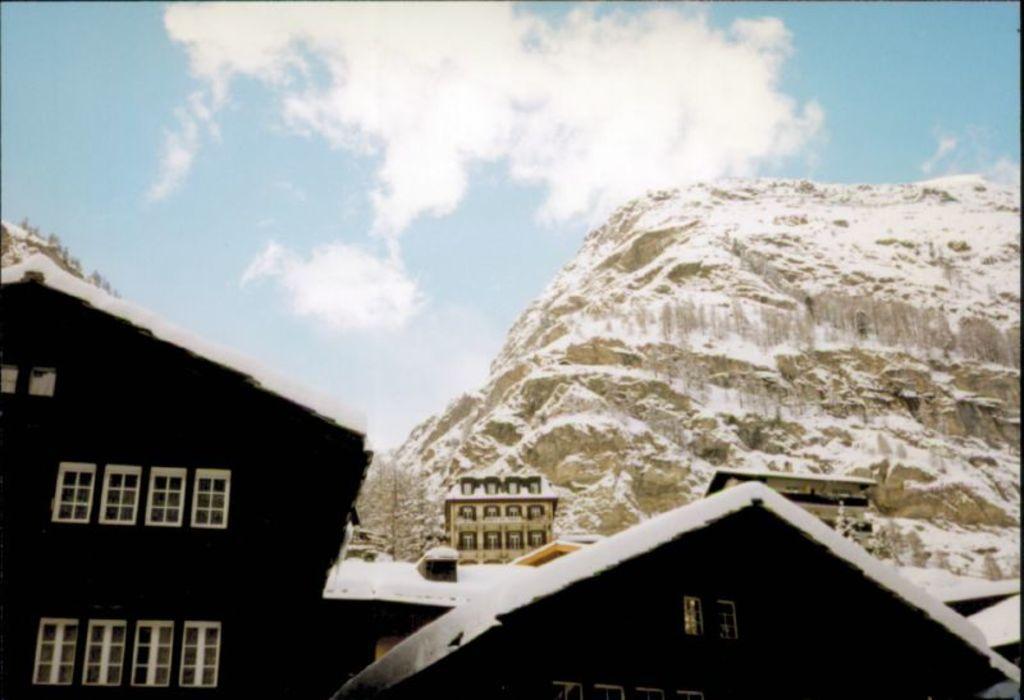Describe this image in one or two sentences. There are houses in this picture and there are windows in these houses. Behind the houses there is a hill and in the background we can observe clouds and sky. 